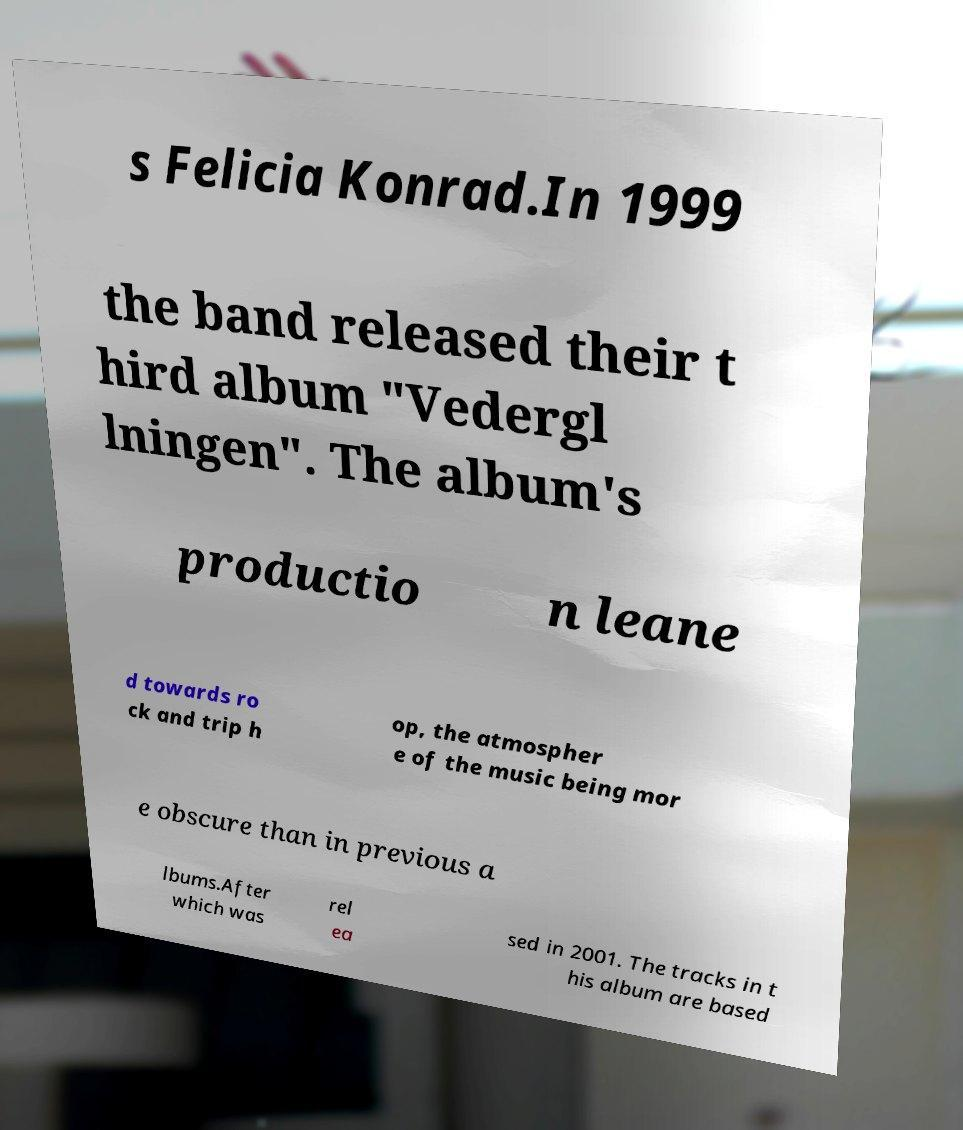There's text embedded in this image that I need extracted. Can you transcribe it verbatim? s Felicia Konrad.In 1999 the band released their t hird album "Vedergl lningen". The album's productio n leane d towards ro ck and trip h op, the atmospher e of the music being mor e obscure than in previous a lbums.After which was rel ea sed in 2001. The tracks in t his album are based 